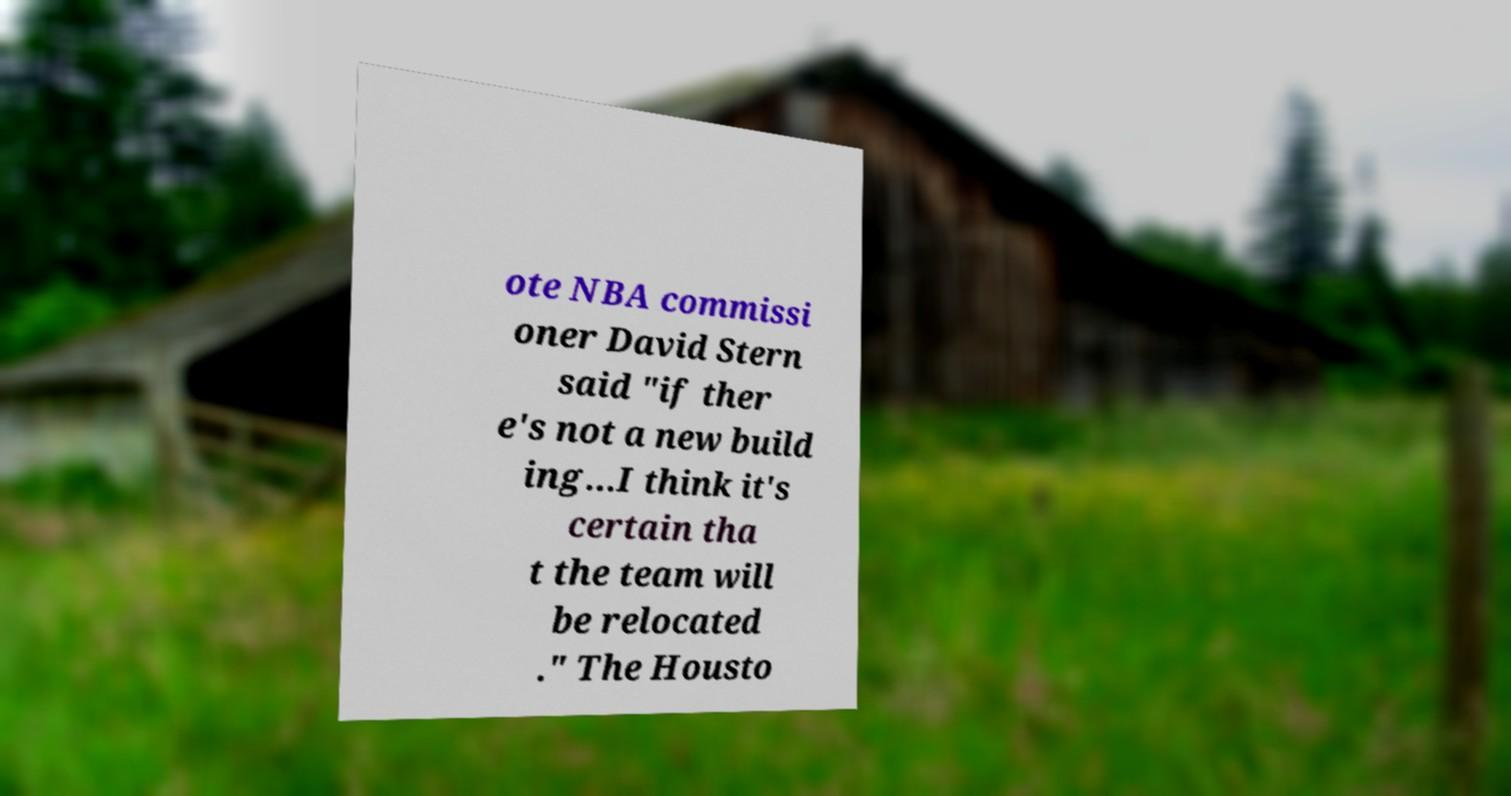What messages or text are displayed in this image? I need them in a readable, typed format. ote NBA commissi oner David Stern said "if ther e's not a new build ing...I think it's certain tha t the team will be relocated ." The Housto 